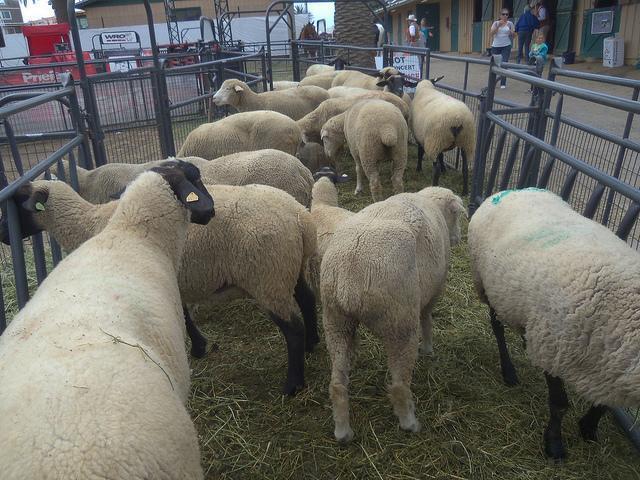How many sheep are in the photo?
Give a very brief answer. 11. How many cows are in the photo?
Give a very brief answer. 0. 